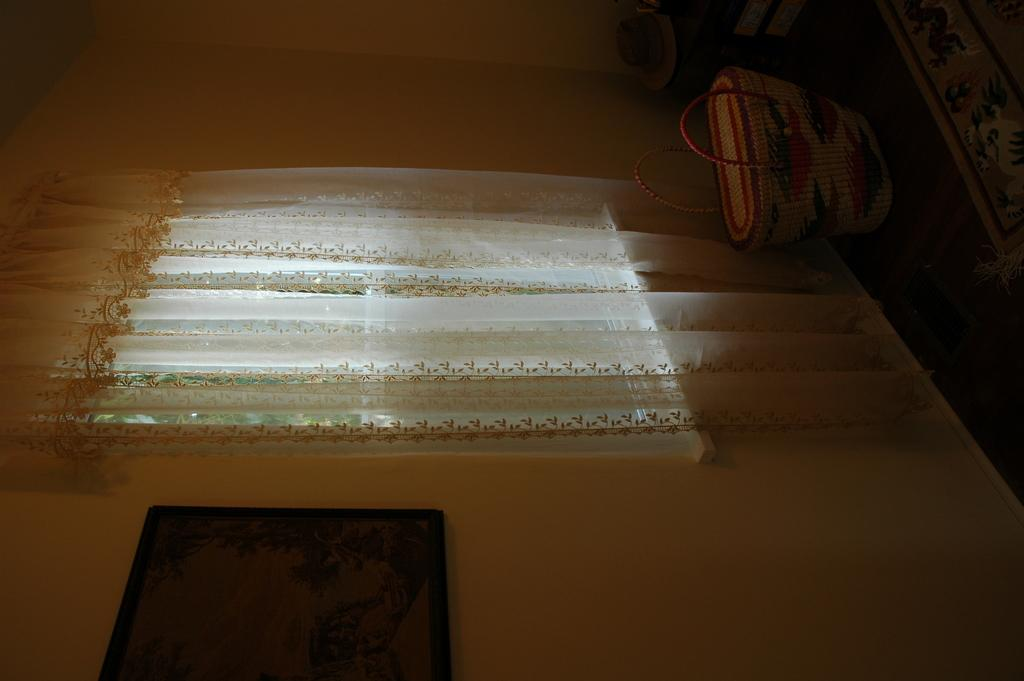What is the main subject in the foreground of the image? There is a wall painting in the foreground of the image. Where is the wall painting located? The wall painting is on a wall. What other feature can be seen in the foreground of the image? There is a window in the foreground of the image. What is visible in the background of the image? There is a bag on the floor and other objects visible in the background of the image. Can you describe the setting of the image? The image is likely taken in a room. What type of zebra can be seen in the image? There is no zebra present in the image. What is the cause of the surprise in the image? There is no surprise or any indication of surprise in the image. 